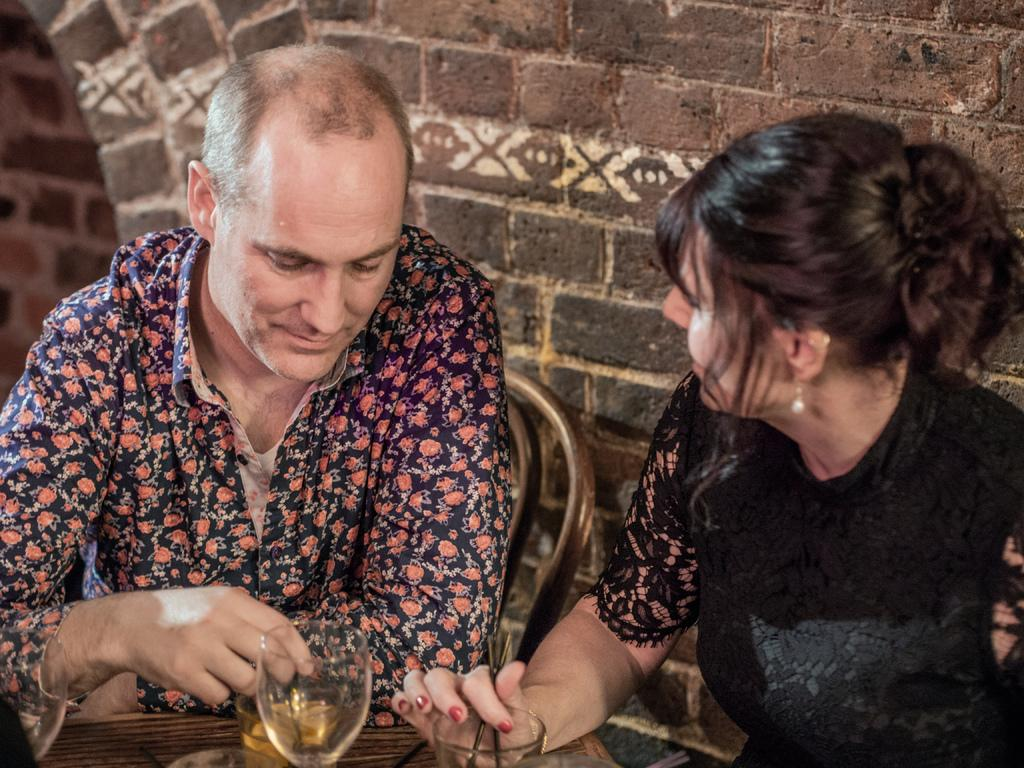How many people are present in the image? There are two people in the image, a man and a woman. What are the man and the woman doing in the image? Both the man and the woman are sitting in a chair. What object can be seen on a table in the image? There is a glass on a table in the image. What type of mitten is the man wearing in the image? There is no mitten present in the image; the man is not wearing any gloves or mittens. What disease is the woman suffering from in the image? There is no indication of any disease or medical condition in the image; the woman appears to be sitting in a chair like the man. 